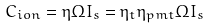Convert formula to latex. <formula><loc_0><loc_0><loc_500><loc_500>C _ { i o n } = \eta \Omega I _ { s } = \eta _ { t } \eta _ { p m t } \Omega I _ { s }</formula> 